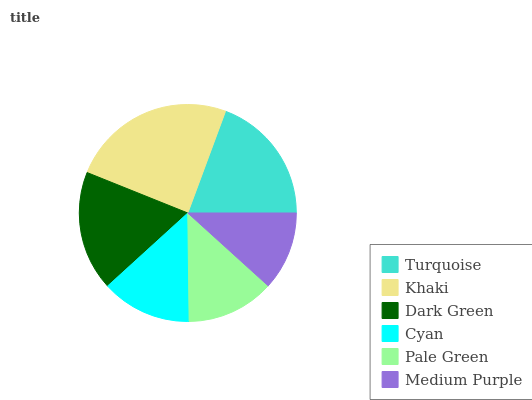Is Medium Purple the minimum?
Answer yes or no. Yes. Is Khaki the maximum?
Answer yes or no. Yes. Is Dark Green the minimum?
Answer yes or no. No. Is Dark Green the maximum?
Answer yes or no. No. Is Khaki greater than Dark Green?
Answer yes or no. Yes. Is Dark Green less than Khaki?
Answer yes or no. Yes. Is Dark Green greater than Khaki?
Answer yes or no. No. Is Khaki less than Dark Green?
Answer yes or no. No. Is Dark Green the high median?
Answer yes or no. Yes. Is Cyan the low median?
Answer yes or no. Yes. Is Pale Green the high median?
Answer yes or no. No. Is Dark Green the low median?
Answer yes or no. No. 